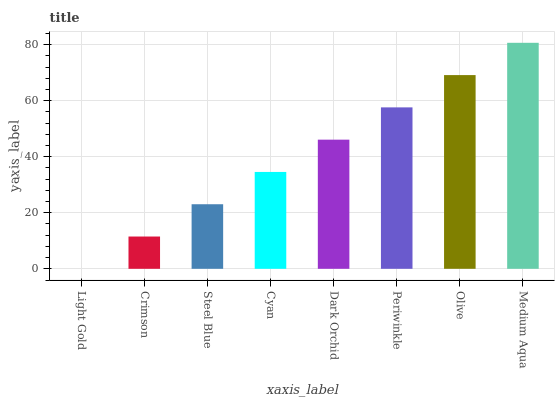Is Light Gold the minimum?
Answer yes or no. Yes. Is Medium Aqua the maximum?
Answer yes or no. Yes. Is Crimson the minimum?
Answer yes or no. No. Is Crimson the maximum?
Answer yes or no. No. Is Crimson greater than Light Gold?
Answer yes or no. Yes. Is Light Gold less than Crimson?
Answer yes or no. Yes. Is Light Gold greater than Crimson?
Answer yes or no. No. Is Crimson less than Light Gold?
Answer yes or no. No. Is Dark Orchid the high median?
Answer yes or no. Yes. Is Cyan the low median?
Answer yes or no. Yes. Is Crimson the high median?
Answer yes or no. No. Is Dark Orchid the low median?
Answer yes or no. No. 